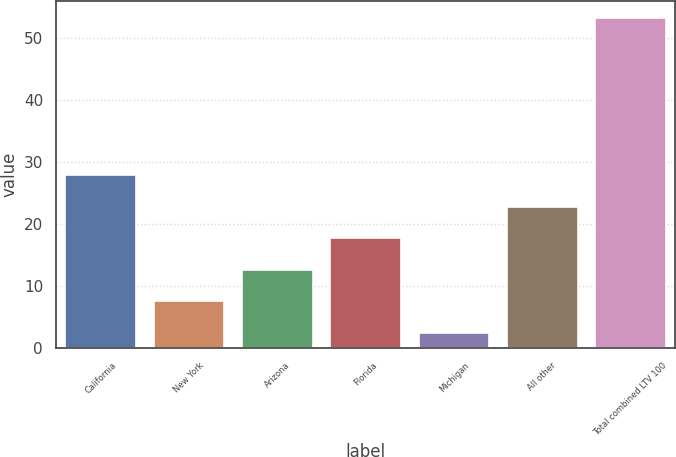Convert chart. <chart><loc_0><loc_0><loc_500><loc_500><bar_chart><fcel>California<fcel>New York<fcel>Arizona<fcel>Florida<fcel>Michigan<fcel>All other<fcel>Total combined LTV 100<nl><fcel>27.8<fcel>7.48<fcel>12.56<fcel>17.64<fcel>2.4<fcel>22.72<fcel>53.2<nl></chart> 